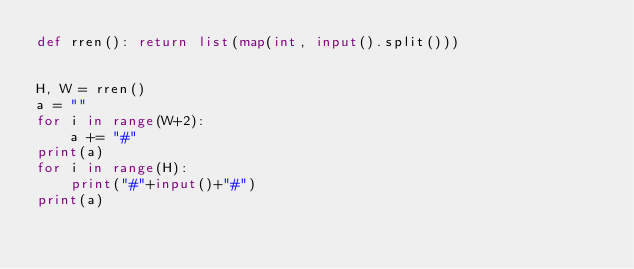Convert code to text. <code><loc_0><loc_0><loc_500><loc_500><_Python_>def rren(): return list(map(int, input().split()))


H, W = rren()
a = ""
for i in range(W+2):
    a += "#"
print(a)
for i in range(H):
    print("#"+input()+"#")
print(a)

</code> 